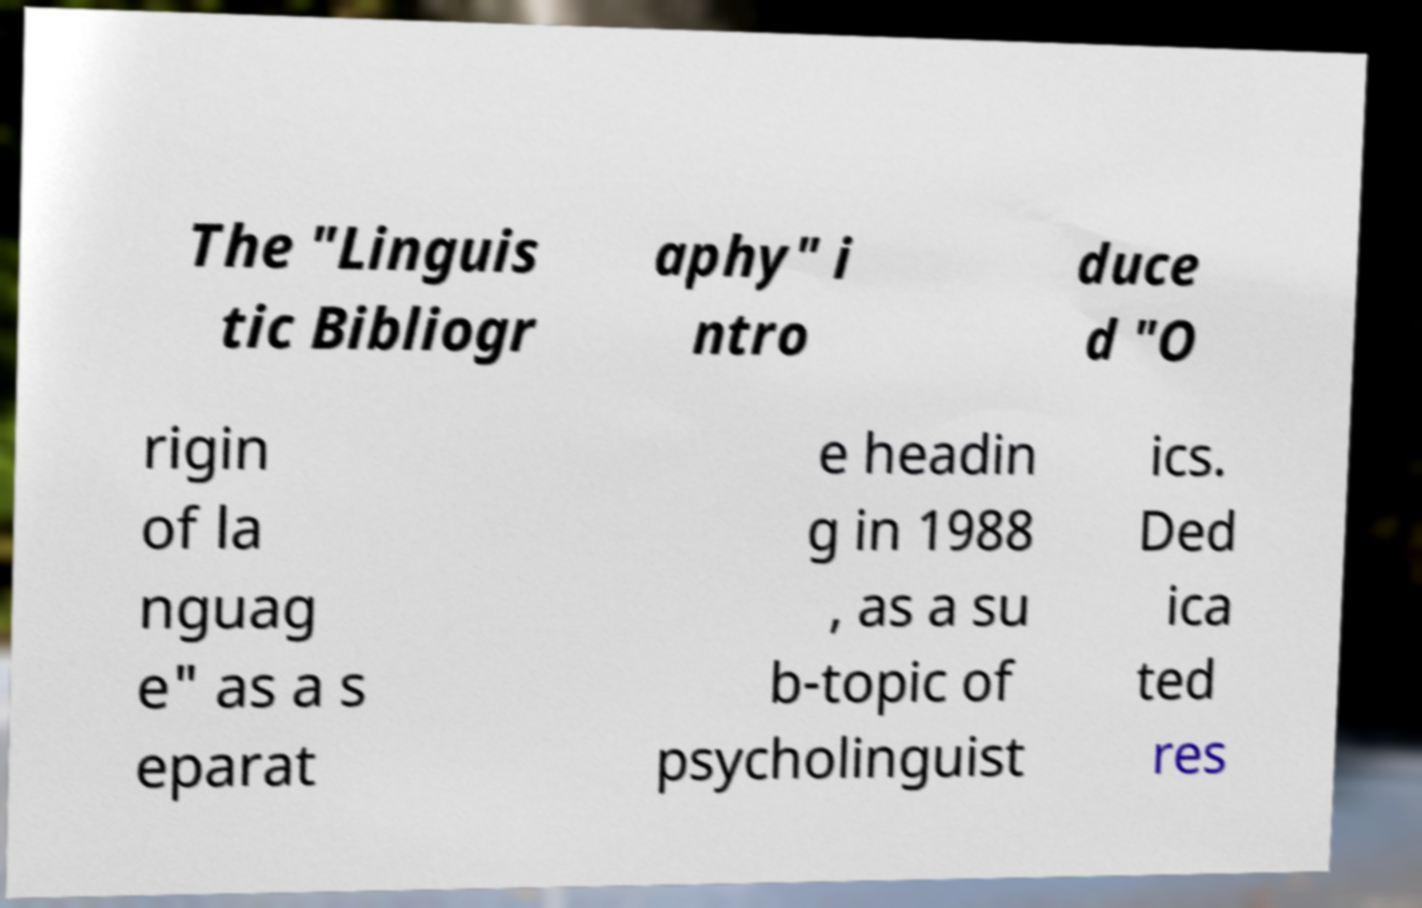Could you assist in decoding the text presented in this image and type it out clearly? The "Linguis tic Bibliogr aphy" i ntro duce d "O rigin of la nguag e" as a s eparat e headin g in 1988 , as a su b-topic of psycholinguist ics. Ded ica ted res 